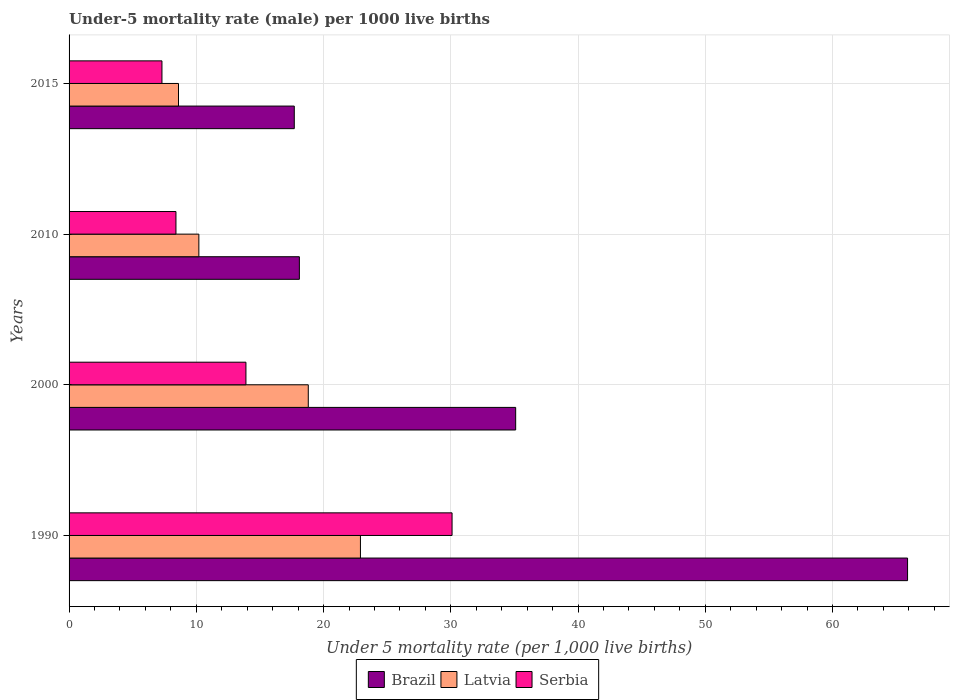How many different coloured bars are there?
Give a very brief answer. 3. Are the number of bars per tick equal to the number of legend labels?
Give a very brief answer. Yes. Are the number of bars on each tick of the Y-axis equal?
Offer a very short reply. Yes. How many bars are there on the 1st tick from the bottom?
Provide a succinct answer. 3. What is the label of the 1st group of bars from the top?
Offer a very short reply. 2015. What is the under-five mortality rate in Latvia in 2000?
Your answer should be compact. 18.8. Across all years, what is the maximum under-five mortality rate in Serbia?
Make the answer very short. 30.1. In which year was the under-five mortality rate in Latvia minimum?
Provide a short and direct response. 2015. What is the total under-five mortality rate in Serbia in the graph?
Provide a succinct answer. 59.7. What is the difference between the under-five mortality rate in Serbia in 1990 and the under-five mortality rate in Latvia in 2010?
Your answer should be compact. 19.9. What is the average under-five mortality rate in Brazil per year?
Ensure brevity in your answer.  34.2. In the year 1990, what is the difference between the under-five mortality rate in Serbia and under-five mortality rate in Latvia?
Give a very brief answer. 7.2. In how many years, is the under-five mortality rate in Serbia greater than 44 ?
Make the answer very short. 0. What is the ratio of the under-five mortality rate in Serbia in 2000 to that in 2010?
Provide a short and direct response. 1.65. Is the under-five mortality rate in Serbia in 2000 less than that in 2010?
Provide a succinct answer. No. Is the difference between the under-five mortality rate in Serbia in 1990 and 2015 greater than the difference between the under-five mortality rate in Latvia in 1990 and 2015?
Provide a short and direct response. Yes. What is the difference between the highest and the second highest under-five mortality rate in Brazil?
Make the answer very short. 30.8. What is the difference between the highest and the lowest under-five mortality rate in Serbia?
Offer a terse response. 22.8. What does the 3rd bar from the bottom in 2000 represents?
Give a very brief answer. Serbia. Is it the case that in every year, the sum of the under-five mortality rate in Brazil and under-five mortality rate in Serbia is greater than the under-five mortality rate in Latvia?
Make the answer very short. Yes. How many bars are there?
Keep it short and to the point. 12. Are all the bars in the graph horizontal?
Provide a short and direct response. Yes. What is the difference between two consecutive major ticks on the X-axis?
Your answer should be very brief. 10. Are the values on the major ticks of X-axis written in scientific E-notation?
Keep it short and to the point. No. Does the graph contain grids?
Keep it short and to the point. Yes. Where does the legend appear in the graph?
Keep it short and to the point. Bottom center. What is the title of the graph?
Ensure brevity in your answer.  Under-5 mortality rate (male) per 1000 live births. What is the label or title of the X-axis?
Offer a very short reply. Under 5 mortality rate (per 1,0 live births). What is the Under 5 mortality rate (per 1,000 live births) in Brazil in 1990?
Offer a terse response. 65.9. What is the Under 5 mortality rate (per 1,000 live births) in Latvia in 1990?
Your answer should be compact. 22.9. What is the Under 5 mortality rate (per 1,000 live births) of Serbia in 1990?
Make the answer very short. 30.1. What is the Under 5 mortality rate (per 1,000 live births) in Brazil in 2000?
Provide a short and direct response. 35.1. What is the Under 5 mortality rate (per 1,000 live births) in Latvia in 2000?
Provide a short and direct response. 18.8. What is the Under 5 mortality rate (per 1,000 live births) of Latvia in 2015?
Keep it short and to the point. 8.6. Across all years, what is the maximum Under 5 mortality rate (per 1,000 live births) of Brazil?
Make the answer very short. 65.9. Across all years, what is the maximum Under 5 mortality rate (per 1,000 live births) of Latvia?
Your response must be concise. 22.9. Across all years, what is the maximum Under 5 mortality rate (per 1,000 live births) of Serbia?
Provide a succinct answer. 30.1. What is the total Under 5 mortality rate (per 1,000 live births) in Brazil in the graph?
Ensure brevity in your answer.  136.8. What is the total Under 5 mortality rate (per 1,000 live births) in Latvia in the graph?
Keep it short and to the point. 60.5. What is the total Under 5 mortality rate (per 1,000 live births) of Serbia in the graph?
Keep it short and to the point. 59.7. What is the difference between the Under 5 mortality rate (per 1,000 live births) in Brazil in 1990 and that in 2000?
Make the answer very short. 30.8. What is the difference between the Under 5 mortality rate (per 1,000 live births) in Latvia in 1990 and that in 2000?
Keep it short and to the point. 4.1. What is the difference between the Under 5 mortality rate (per 1,000 live births) in Serbia in 1990 and that in 2000?
Your answer should be very brief. 16.2. What is the difference between the Under 5 mortality rate (per 1,000 live births) in Brazil in 1990 and that in 2010?
Ensure brevity in your answer.  47.8. What is the difference between the Under 5 mortality rate (per 1,000 live births) in Latvia in 1990 and that in 2010?
Make the answer very short. 12.7. What is the difference between the Under 5 mortality rate (per 1,000 live births) in Serbia in 1990 and that in 2010?
Provide a short and direct response. 21.7. What is the difference between the Under 5 mortality rate (per 1,000 live births) of Brazil in 1990 and that in 2015?
Ensure brevity in your answer.  48.2. What is the difference between the Under 5 mortality rate (per 1,000 live births) in Serbia in 1990 and that in 2015?
Your answer should be very brief. 22.8. What is the difference between the Under 5 mortality rate (per 1,000 live births) in Brazil in 2000 and that in 2015?
Provide a short and direct response. 17.4. What is the difference between the Under 5 mortality rate (per 1,000 live births) of Latvia in 2000 and that in 2015?
Offer a very short reply. 10.2. What is the difference between the Under 5 mortality rate (per 1,000 live births) of Serbia in 2000 and that in 2015?
Provide a short and direct response. 6.6. What is the difference between the Under 5 mortality rate (per 1,000 live births) in Latvia in 2010 and that in 2015?
Make the answer very short. 1.6. What is the difference between the Under 5 mortality rate (per 1,000 live births) of Brazil in 1990 and the Under 5 mortality rate (per 1,000 live births) of Latvia in 2000?
Your response must be concise. 47.1. What is the difference between the Under 5 mortality rate (per 1,000 live births) in Brazil in 1990 and the Under 5 mortality rate (per 1,000 live births) in Serbia in 2000?
Offer a very short reply. 52. What is the difference between the Under 5 mortality rate (per 1,000 live births) in Brazil in 1990 and the Under 5 mortality rate (per 1,000 live births) in Latvia in 2010?
Your response must be concise. 55.7. What is the difference between the Under 5 mortality rate (per 1,000 live births) in Brazil in 1990 and the Under 5 mortality rate (per 1,000 live births) in Serbia in 2010?
Your response must be concise. 57.5. What is the difference between the Under 5 mortality rate (per 1,000 live births) in Latvia in 1990 and the Under 5 mortality rate (per 1,000 live births) in Serbia in 2010?
Give a very brief answer. 14.5. What is the difference between the Under 5 mortality rate (per 1,000 live births) of Brazil in 1990 and the Under 5 mortality rate (per 1,000 live births) of Latvia in 2015?
Make the answer very short. 57.3. What is the difference between the Under 5 mortality rate (per 1,000 live births) in Brazil in 1990 and the Under 5 mortality rate (per 1,000 live births) in Serbia in 2015?
Offer a terse response. 58.6. What is the difference between the Under 5 mortality rate (per 1,000 live births) in Latvia in 1990 and the Under 5 mortality rate (per 1,000 live births) in Serbia in 2015?
Your answer should be very brief. 15.6. What is the difference between the Under 5 mortality rate (per 1,000 live births) of Brazil in 2000 and the Under 5 mortality rate (per 1,000 live births) of Latvia in 2010?
Offer a very short reply. 24.9. What is the difference between the Under 5 mortality rate (per 1,000 live births) of Brazil in 2000 and the Under 5 mortality rate (per 1,000 live births) of Serbia in 2010?
Provide a succinct answer. 26.7. What is the difference between the Under 5 mortality rate (per 1,000 live births) of Latvia in 2000 and the Under 5 mortality rate (per 1,000 live births) of Serbia in 2010?
Your answer should be very brief. 10.4. What is the difference between the Under 5 mortality rate (per 1,000 live births) of Brazil in 2000 and the Under 5 mortality rate (per 1,000 live births) of Latvia in 2015?
Ensure brevity in your answer.  26.5. What is the difference between the Under 5 mortality rate (per 1,000 live births) in Brazil in 2000 and the Under 5 mortality rate (per 1,000 live births) in Serbia in 2015?
Offer a terse response. 27.8. What is the difference between the Under 5 mortality rate (per 1,000 live births) of Brazil in 2010 and the Under 5 mortality rate (per 1,000 live births) of Latvia in 2015?
Give a very brief answer. 9.5. What is the difference between the Under 5 mortality rate (per 1,000 live births) in Brazil in 2010 and the Under 5 mortality rate (per 1,000 live births) in Serbia in 2015?
Offer a terse response. 10.8. What is the difference between the Under 5 mortality rate (per 1,000 live births) in Latvia in 2010 and the Under 5 mortality rate (per 1,000 live births) in Serbia in 2015?
Make the answer very short. 2.9. What is the average Under 5 mortality rate (per 1,000 live births) of Brazil per year?
Your answer should be compact. 34.2. What is the average Under 5 mortality rate (per 1,000 live births) of Latvia per year?
Ensure brevity in your answer.  15.12. What is the average Under 5 mortality rate (per 1,000 live births) of Serbia per year?
Your answer should be compact. 14.93. In the year 1990, what is the difference between the Under 5 mortality rate (per 1,000 live births) of Brazil and Under 5 mortality rate (per 1,000 live births) of Latvia?
Your answer should be compact. 43. In the year 1990, what is the difference between the Under 5 mortality rate (per 1,000 live births) in Brazil and Under 5 mortality rate (per 1,000 live births) in Serbia?
Provide a succinct answer. 35.8. In the year 2000, what is the difference between the Under 5 mortality rate (per 1,000 live births) in Brazil and Under 5 mortality rate (per 1,000 live births) in Serbia?
Your answer should be very brief. 21.2. In the year 2010, what is the difference between the Under 5 mortality rate (per 1,000 live births) of Brazil and Under 5 mortality rate (per 1,000 live births) of Serbia?
Your response must be concise. 9.7. In the year 2015, what is the difference between the Under 5 mortality rate (per 1,000 live births) in Brazil and Under 5 mortality rate (per 1,000 live births) in Serbia?
Offer a very short reply. 10.4. In the year 2015, what is the difference between the Under 5 mortality rate (per 1,000 live births) of Latvia and Under 5 mortality rate (per 1,000 live births) of Serbia?
Offer a terse response. 1.3. What is the ratio of the Under 5 mortality rate (per 1,000 live births) of Brazil in 1990 to that in 2000?
Your answer should be compact. 1.88. What is the ratio of the Under 5 mortality rate (per 1,000 live births) of Latvia in 1990 to that in 2000?
Provide a succinct answer. 1.22. What is the ratio of the Under 5 mortality rate (per 1,000 live births) in Serbia in 1990 to that in 2000?
Give a very brief answer. 2.17. What is the ratio of the Under 5 mortality rate (per 1,000 live births) of Brazil in 1990 to that in 2010?
Keep it short and to the point. 3.64. What is the ratio of the Under 5 mortality rate (per 1,000 live births) in Latvia in 1990 to that in 2010?
Your answer should be very brief. 2.25. What is the ratio of the Under 5 mortality rate (per 1,000 live births) of Serbia in 1990 to that in 2010?
Keep it short and to the point. 3.58. What is the ratio of the Under 5 mortality rate (per 1,000 live births) in Brazil in 1990 to that in 2015?
Your answer should be compact. 3.72. What is the ratio of the Under 5 mortality rate (per 1,000 live births) in Latvia in 1990 to that in 2015?
Your response must be concise. 2.66. What is the ratio of the Under 5 mortality rate (per 1,000 live births) in Serbia in 1990 to that in 2015?
Provide a succinct answer. 4.12. What is the ratio of the Under 5 mortality rate (per 1,000 live births) of Brazil in 2000 to that in 2010?
Ensure brevity in your answer.  1.94. What is the ratio of the Under 5 mortality rate (per 1,000 live births) of Latvia in 2000 to that in 2010?
Provide a succinct answer. 1.84. What is the ratio of the Under 5 mortality rate (per 1,000 live births) of Serbia in 2000 to that in 2010?
Your answer should be compact. 1.65. What is the ratio of the Under 5 mortality rate (per 1,000 live births) in Brazil in 2000 to that in 2015?
Make the answer very short. 1.98. What is the ratio of the Under 5 mortality rate (per 1,000 live births) in Latvia in 2000 to that in 2015?
Give a very brief answer. 2.19. What is the ratio of the Under 5 mortality rate (per 1,000 live births) of Serbia in 2000 to that in 2015?
Keep it short and to the point. 1.9. What is the ratio of the Under 5 mortality rate (per 1,000 live births) of Brazil in 2010 to that in 2015?
Offer a very short reply. 1.02. What is the ratio of the Under 5 mortality rate (per 1,000 live births) in Latvia in 2010 to that in 2015?
Your response must be concise. 1.19. What is the ratio of the Under 5 mortality rate (per 1,000 live births) in Serbia in 2010 to that in 2015?
Provide a short and direct response. 1.15. What is the difference between the highest and the second highest Under 5 mortality rate (per 1,000 live births) of Brazil?
Your answer should be very brief. 30.8. What is the difference between the highest and the second highest Under 5 mortality rate (per 1,000 live births) in Latvia?
Your answer should be very brief. 4.1. What is the difference between the highest and the lowest Under 5 mortality rate (per 1,000 live births) of Brazil?
Provide a succinct answer. 48.2. What is the difference between the highest and the lowest Under 5 mortality rate (per 1,000 live births) of Serbia?
Your response must be concise. 22.8. 